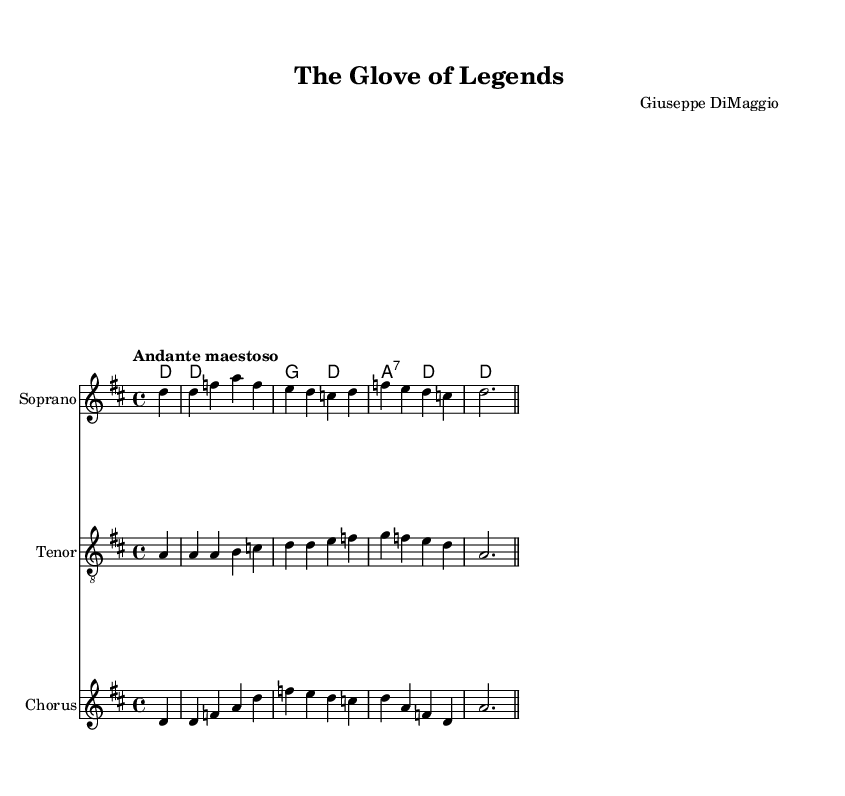What is the key signature of this music? The key signature indicates two sharps, which corresponds to D major. The key is typically noted at the beginning of the staff.
Answer: D major What is the time signature of this music? The time signature is found at the beginning of the score, displayed as 4/4. This means there are four beats per measure and the quarter note gets one beat.
Answer: 4/4 What is the tempo marking for this piece? The tempo marking is written at the start and indicates the character of the music. Here, the term "Andante maestoso" suggests a moderately slow tempo with grandeur.
Answer: Andante maestoso How many voices are present in this score? There are three distinct voices indicated in the score: Soprano, Tenor, and Chorus, each represented by a separate staff. The title and structure suggest a multi-voiced operatic form.
Answer: Three Which instrument is indicated for the Soprano part? The instrument for the Soprano part is specified directly in the score’s staff label. It states "Soprano," indicating that this voice is intended for a soprano singer.
Answer: Soprano What do the lyrics in the Soprano part highlight? The lyrics of the Soprano part mention "The leather, worn and weathered," which reflects a poetic imagery connected to the craftsmanship of baseball mitts. The text reflects the historical aspect related to the sport.
Answer: The leather, worn and weathered How does the Chorus's lyric connect to the story of baseball? The Chorus's lyrics "From the factory to the field, each stitch with pride" emphasize the thematic connection between the production of baseball mitts and their use in the sport, blending craftsmanship with athleticism.
Answer: Each stitch with pride 